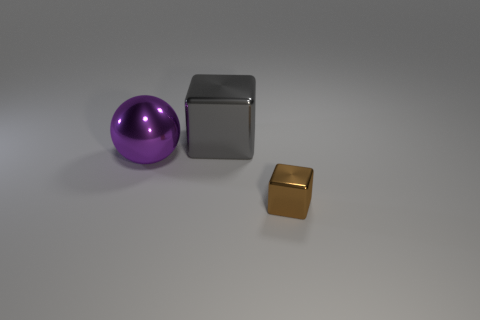Is there anything else that has the same size as the brown object?
Ensure brevity in your answer.  No. The other small thing that is the same shape as the gray thing is what color?
Your answer should be very brief. Brown. What number of things are in front of the gray metal thing and on the left side of the tiny thing?
Offer a terse response. 1. Are there more big gray metal things that are to the left of the big purple metal thing than small metallic blocks on the right side of the small brown metal object?
Your answer should be very brief. No. What is the size of the gray block?
Keep it short and to the point. Large. Are there any other big shiny objects that have the same shape as the big purple shiny thing?
Your answer should be very brief. No. There is a purple metallic thing; does it have the same shape as the metallic object behind the purple metallic thing?
Your answer should be compact. No. What size is the metal thing that is to the left of the tiny object and on the right side of the ball?
Your response must be concise. Large. What number of brown metal cubes are there?
Provide a short and direct response. 1. There is a ball that is the same size as the gray thing; what material is it?
Provide a succinct answer. Metal. 